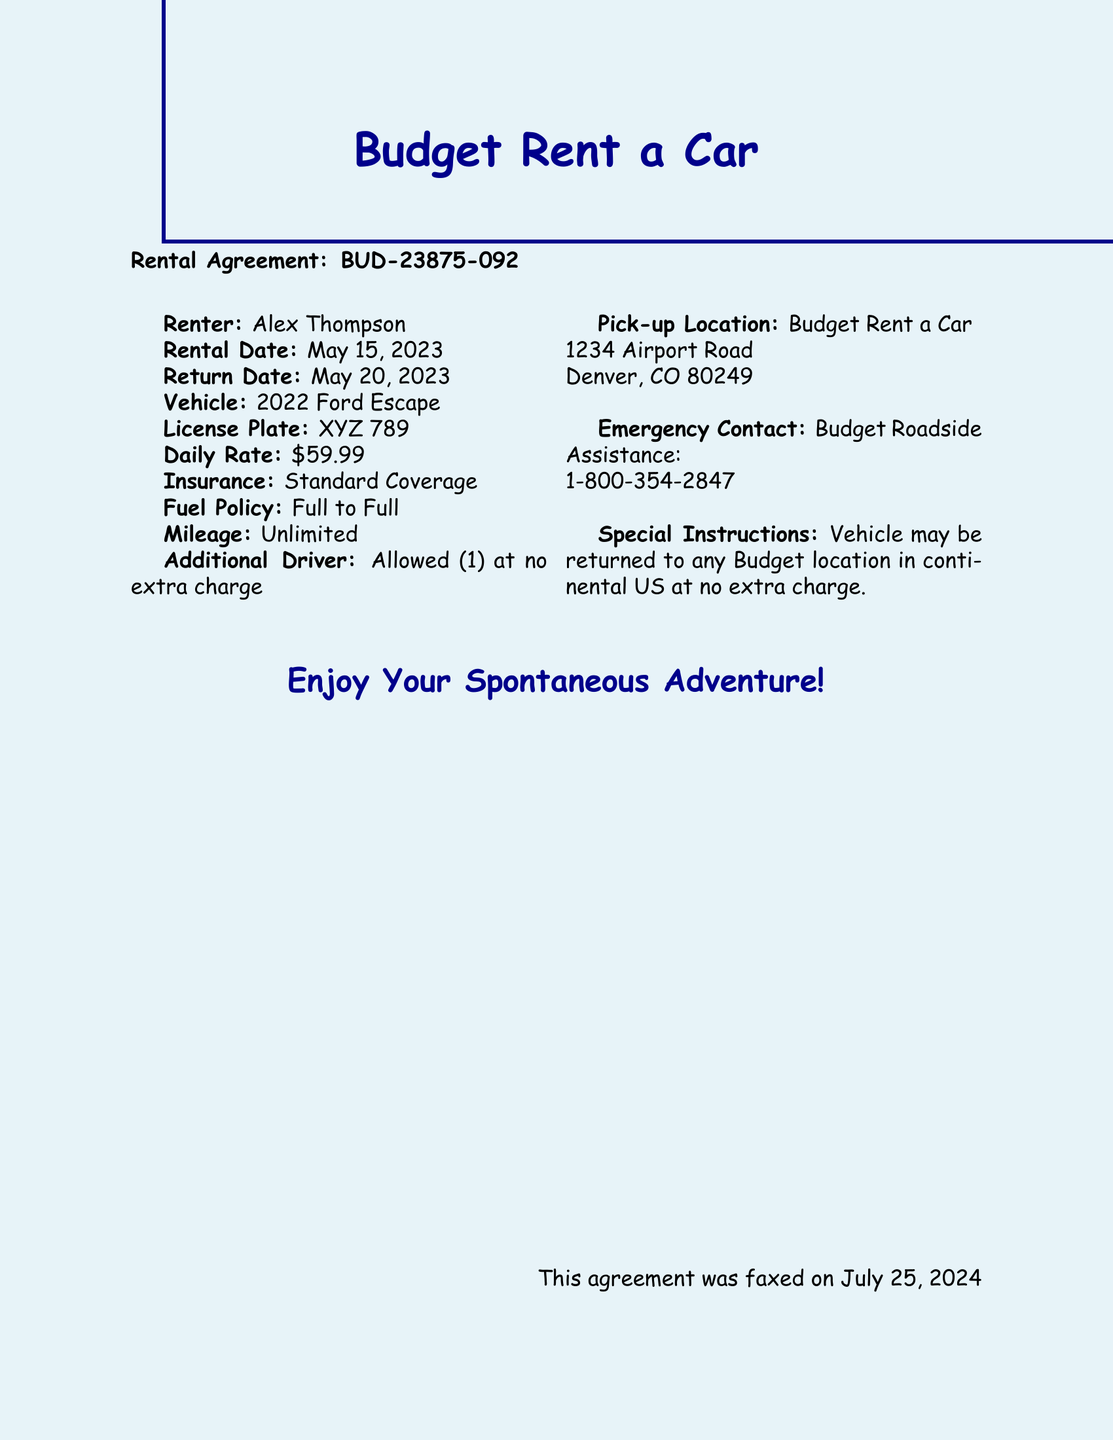What is the name of the renter? The name of the renter is explicitly stated in the document as Alex Thompson.
Answer: Alex Thompson What is the rental start date? The rental start date is provided in the document under the rental details, which is May 15, 2023.
Answer: May 15, 2023 What type of vehicle is rented? The vehicle type is specified in the agreement, which mentions a 2022 Ford Escape.
Answer: 2022 Ford Escape What is the daily rental rate? The daily rental rate is mentioned in the document as a specific cost, which is $59.99.
Answer: $59.99 Is additional driver allowed? The document states details regarding additional drivers, indicating that it is allowed at no extra charge.
Answer: Allowed (1) What is the pick-up location? The pick-up location is outlined in the document, detailing the address 1234 Airport Road, Denver, CO 80249.
Answer: 1234 Airport Road, Denver, CO 80249 What is the insurance coverage? The insurance coverage type is specified in the document, which states Standard Coverage.
Answer: Standard Coverage What is the fuel policy? The fuel policy is detailed in the document, indicating that it is Full to Full.
Answer: Full to Full Can the vehicle be returned to any location? The document includes information stating that the vehicle may be returned to any Budget location in continental US at no extra charge.
Answer: Yes 